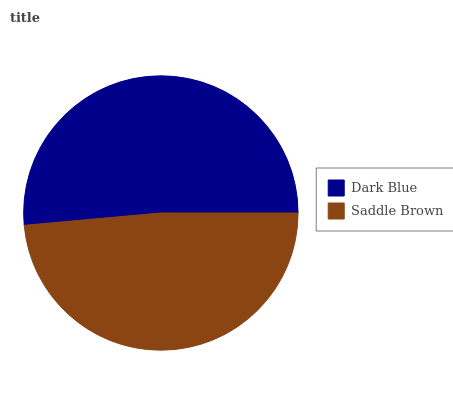Is Saddle Brown the minimum?
Answer yes or no. Yes. Is Dark Blue the maximum?
Answer yes or no. Yes. Is Saddle Brown the maximum?
Answer yes or no. No. Is Dark Blue greater than Saddle Brown?
Answer yes or no. Yes. Is Saddle Brown less than Dark Blue?
Answer yes or no. Yes. Is Saddle Brown greater than Dark Blue?
Answer yes or no. No. Is Dark Blue less than Saddle Brown?
Answer yes or no. No. Is Dark Blue the high median?
Answer yes or no. Yes. Is Saddle Brown the low median?
Answer yes or no. Yes. Is Saddle Brown the high median?
Answer yes or no. No. Is Dark Blue the low median?
Answer yes or no. No. 